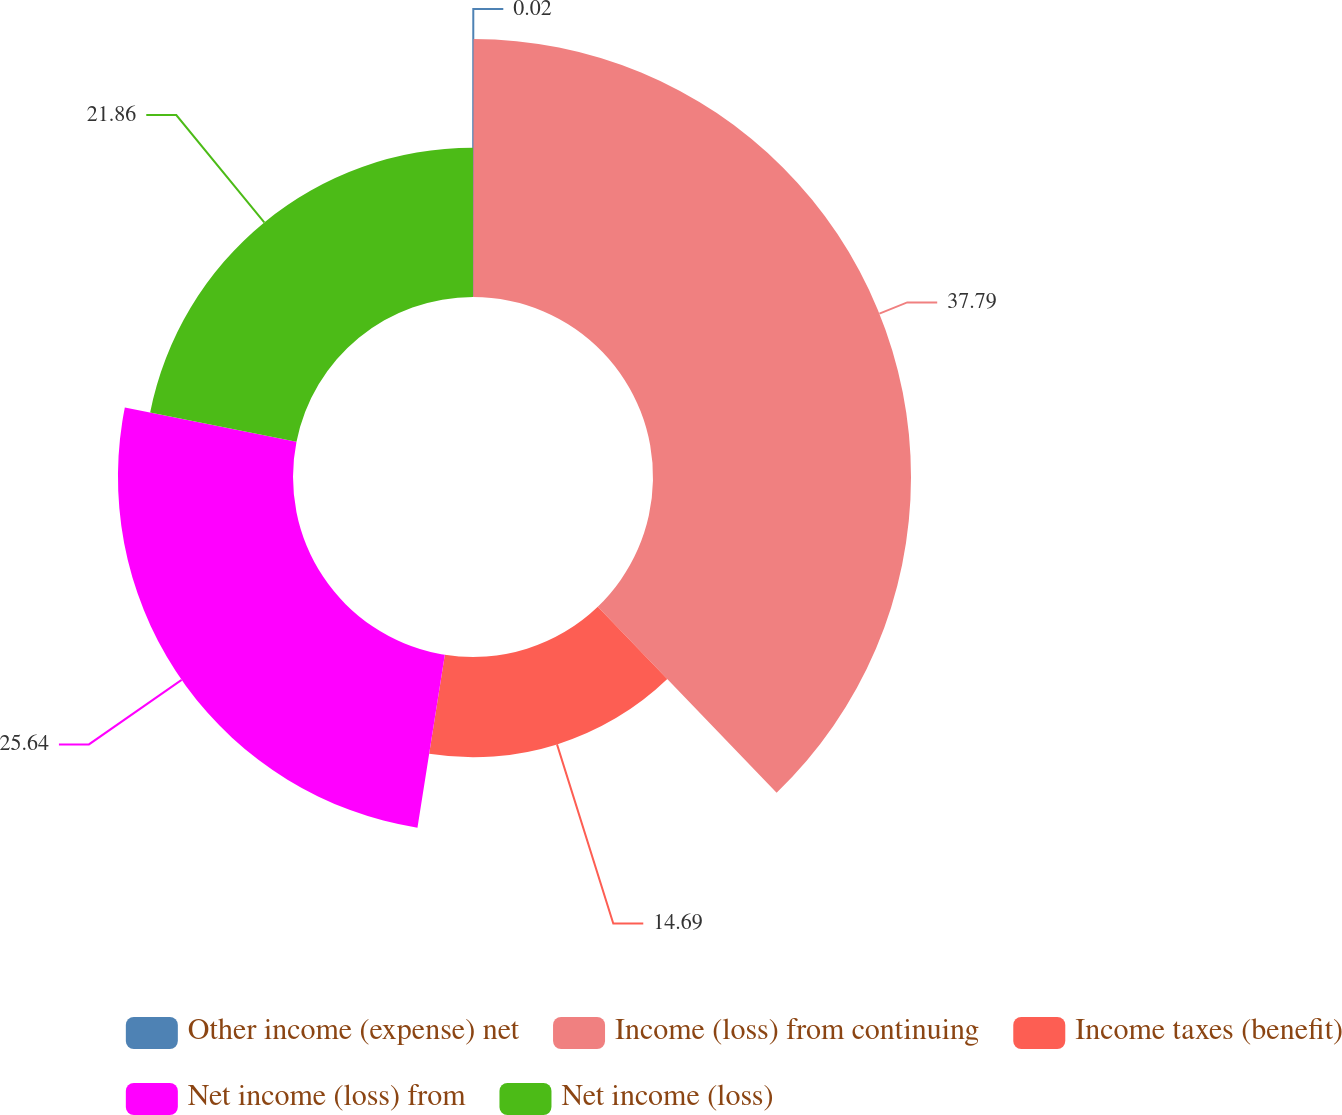Convert chart to OTSL. <chart><loc_0><loc_0><loc_500><loc_500><pie_chart><fcel>Other income (expense) net<fcel>Income (loss) from continuing<fcel>Income taxes (benefit)<fcel>Net income (loss) from<fcel>Net income (loss)<nl><fcel>0.02%<fcel>37.79%<fcel>14.69%<fcel>25.64%<fcel>21.86%<nl></chart> 